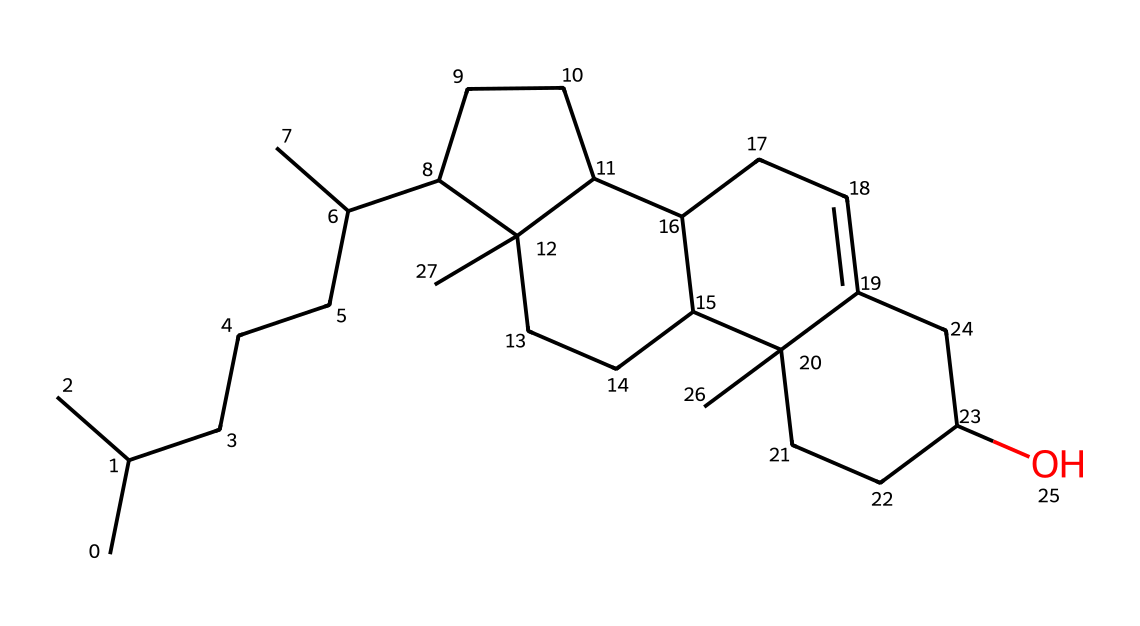What is the primary component of the cellular structure in this chemical? Cholesterol, as represented by the provided SMILES, functions as a major component of cell membranes, contributing to their fluidity and structural integrity.
Answer: cholesterol How many carbon atoms are present in this structure? By analyzing the SMILES representation, we can count the occurrences of the letter "C," representing carbon atoms. The total number is 27.
Answer: 27 What functional group is indicated in this chemical? The hydroxyl group (-OH) is indicated by the "O" at the end of the SMILES, which characterizes cholesterol as a sterol or alcohol.
Answer: hydroxyl What type of lipid is cholesterol classified as? Cholesterol is categorized as a sterol, which is a subtype of steroids. This classification is supported by its structure, which contains multiple fused ring systems.
Answer: sterol Does this chemical structure exhibit any double bonds? Examining the SMILES for the presence of "=" indicates where double bonds occur, and indeed there is one found in the cyclohexene portion of the structure.
Answer: yes What is the overall shape characteristic of cholesterol based on its structure? The fused ring structure of cholesterol gives it a planar, rigid shape, which is crucial for its role in membrane structure and function.
Answer: planar 